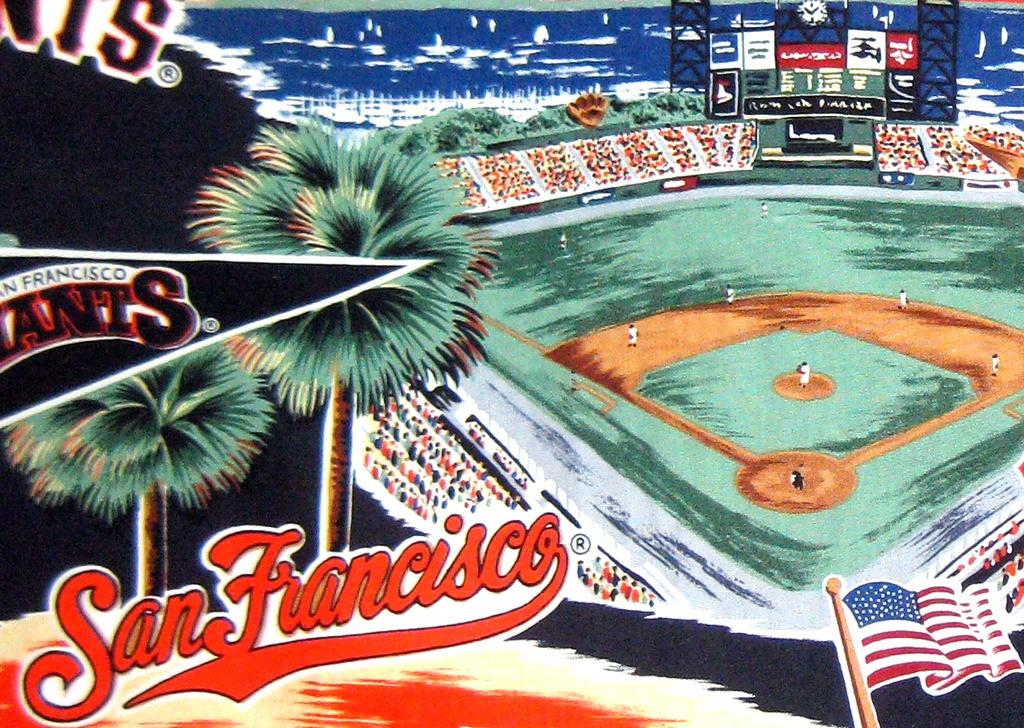Provide a one-sentence caption for the provided image. A San Francisco Giants baseball field with players on the field. 